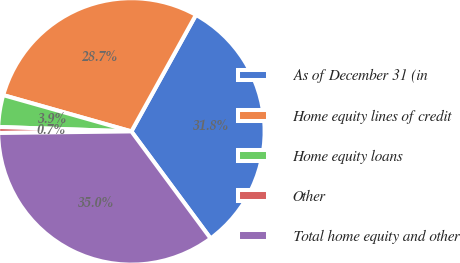Convert chart. <chart><loc_0><loc_0><loc_500><loc_500><pie_chart><fcel>As of December 31 (in<fcel>Home equity lines of credit<fcel>Home equity loans<fcel>Other<fcel>Total home equity and other<nl><fcel>31.81%<fcel>28.66%<fcel>3.86%<fcel>0.72%<fcel>34.95%<nl></chart> 